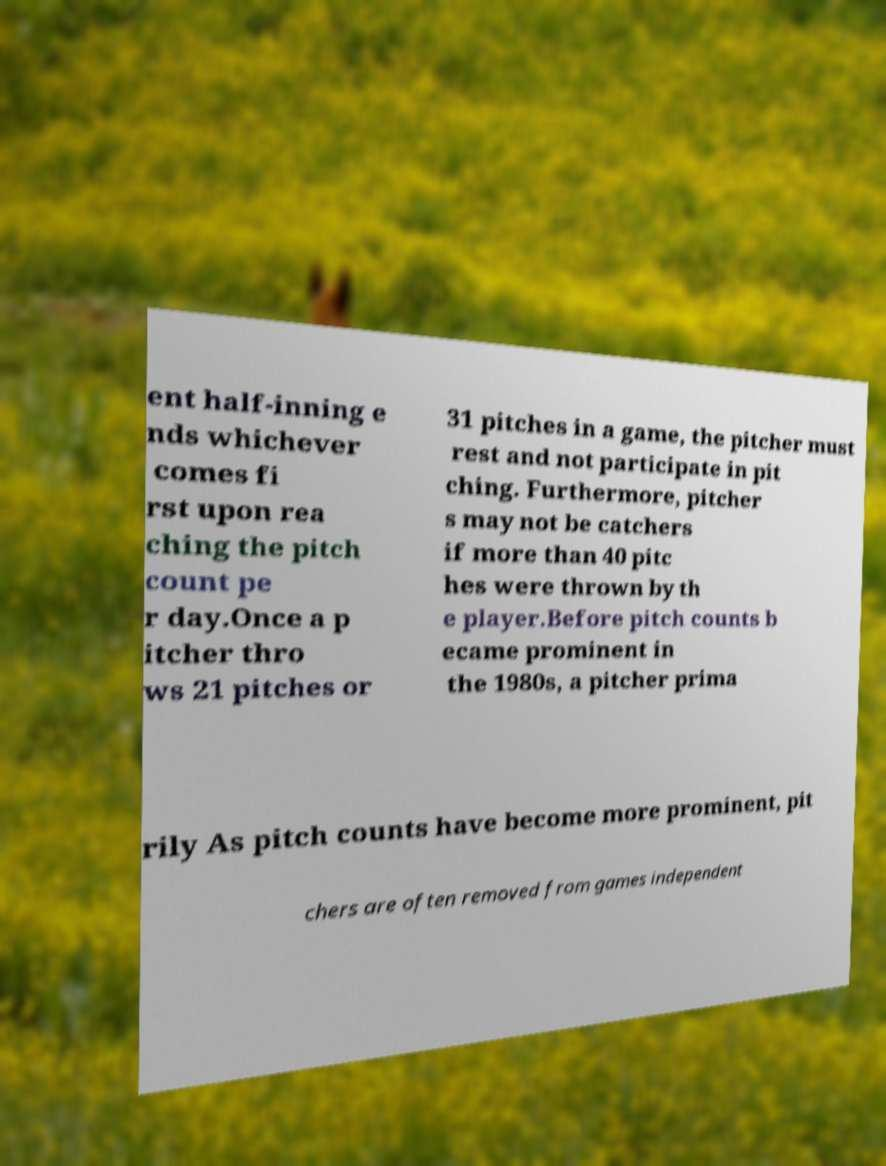Could you extract and type out the text from this image? ent half-inning e nds whichever comes fi rst upon rea ching the pitch count pe r day.Once a p itcher thro ws 21 pitches or 31 pitches in a game, the pitcher must rest and not participate in pit ching. Furthermore, pitcher s may not be catchers if more than 40 pitc hes were thrown by th e player.Before pitch counts b ecame prominent in the 1980s, a pitcher prima rily As pitch counts have become more prominent, pit chers are often removed from games independent 